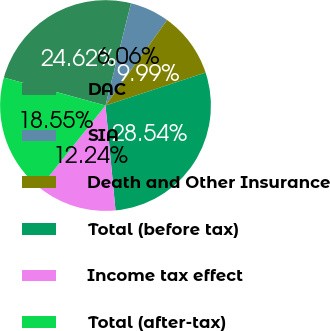<chart> <loc_0><loc_0><loc_500><loc_500><pie_chart><fcel>DAC<fcel>SIA<fcel>Death and Other Insurance<fcel>Total (before tax)<fcel>Income tax effect<fcel>Total (after-tax)<nl><fcel>24.62%<fcel>6.06%<fcel>9.99%<fcel>28.54%<fcel>12.24%<fcel>18.55%<nl></chart> 